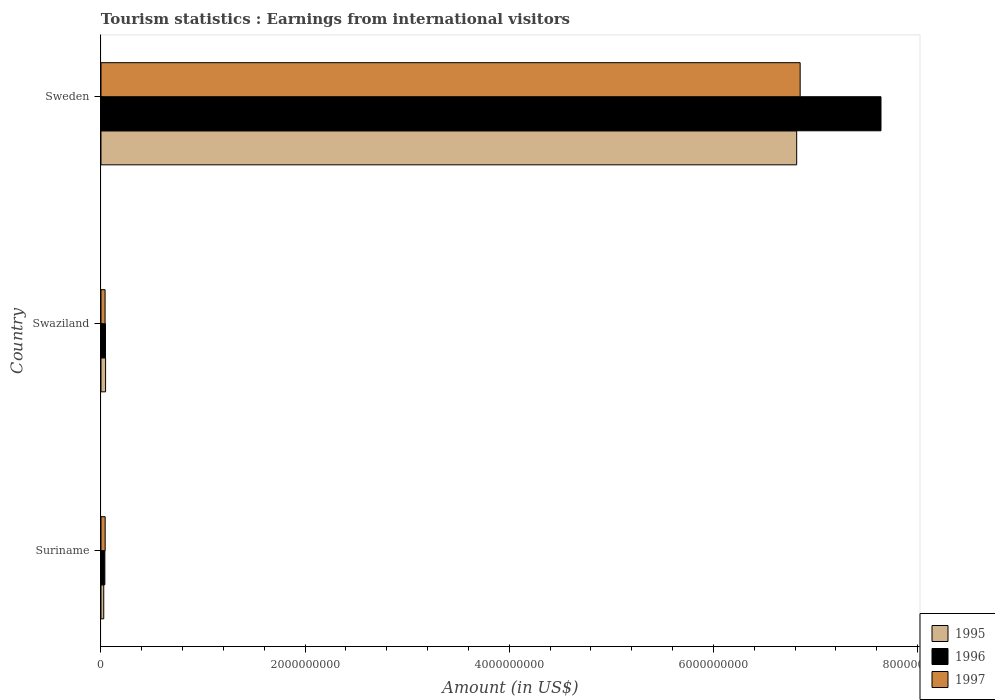How many groups of bars are there?
Offer a very short reply. 3. Are the number of bars per tick equal to the number of legend labels?
Make the answer very short. Yes. How many bars are there on the 2nd tick from the top?
Offer a terse response. 3. What is the earnings from international visitors in 1995 in Swaziland?
Provide a succinct answer. 4.50e+07. Across all countries, what is the maximum earnings from international visitors in 1996?
Keep it short and to the point. 7.64e+09. Across all countries, what is the minimum earnings from international visitors in 1997?
Provide a succinct answer. 4.00e+07. In which country was the earnings from international visitors in 1997 minimum?
Your answer should be compact. Swaziland. What is the total earnings from international visitors in 1997 in the graph?
Offer a very short reply. 6.93e+09. What is the difference between the earnings from international visitors in 1997 in Suriname and that in Sweden?
Offer a terse response. -6.81e+09. What is the difference between the earnings from international visitors in 1996 in Suriname and the earnings from international visitors in 1997 in Sweden?
Offer a very short reply. -6.81e+09. What is the average earnings from international visitors in 1995 per country?
Provide a short and direct response. 2.30e+09. What is the difference between the earnings from international visitors in 1996 and earnings from international visitors in 1997 in Suriname?
Make the answer very short. -3.00e+06. In how many countries, is the earnings from international visitors in 1997 greater than 800000000 US$?
Offer a terse response. 1. What is the ratio of the earnings from international visitors in 1996 in Suriname to that in Swaziland?
Offer a terse response. 0.86. Is the difference between the earnings from international visitors in 1996 in Swaziland and Sweden greater than the difference between the earnings from international visitors in 1997 in Swaziland and Sweden?
Keep it short and to the point. No. What is the difference between the highest and the second highest earnings from international visitors in 1997?
Ensure brevity in your answer.  6.81e+09. What is the difference between the highest and the lowest earnings from international visitors in 1997?
Ensure brevity in your answer.  6.81e+09. In how many countries, is the earnings from international visitors in 1995 greater than the average earnings from international visitors in 1995 taken over all countries?
Your response must be concise. 1. Is the sum of the earnings from international visitors in 1995 in Suriname and Sweden greater than the maximum earnings from international visitors in 1997 across all countries?
Offer a terse response. No. What does the 1st bar from the bottom in Suriname represents?
Ensure brevity in your answer.  1995. How many bars are there?
Your answer should be very brief. 9. Are all the bars in the graph horizontal?
Provide a short and direct response. Yes. Are the values on the major ticks of X-axis written in scientific E-notation?
Keep it short and to the point. No. How are the legend labels stacked?
Give a very brief answer. Vertical. What is the title of the graph?
Give a very brief answer. Tourism statistics : Earnings from international visitors. What is the label or title of the X-axis?
Provide a short and direct response. Amount (in US$). What is the Amount (in US$) of 1995 in Suriname?
Your answer should be compact. 2.70e+07. What is the Amount (in US$) in 1996 in Suriname?
Offer a very short reply. 3.80e+07. What is the Amount (in US$) in 1997 in Suriname?
Ensure brevity in your answer.  4.10e+07. What is the Amount (in US$) in 1995 in Swaziland?
Keep it short and to the point. 4.50e+07. What is the Amount (in US$) in 1996 in Swaziland?
Provide a succinct answer. 4.40e+07. What is the Amount (in US$) in 1997 in Swaziland?
Provide a succinct answer. 4.00e+07. What is the Amount (in US$) in 1995 in Sweden?
Provide a short and direct response. 6.82e+09. What is the Amount (in US$) in 1996 in Sweden?
Provide a succinct answer. 7.64e+09. What is the Amount (in US$) of 1997 in Sweden?
Offer a terse response. 6.85e+09. Across all countries, what is the maximum Amount (in US$) in 1995?
Offer a terse response. 6.82e+09. Across all countries, what is the maximum Amount (in US$) in 1996?
Your response must be concise. 7.64e+09. Across all countries, what is the maximum Amount (in US$) of 1997?
Give a very brief answer. 6.85e+09. Across all countries, what is the minimum Amount (in US$) of 1995?
Provide a short and direct response. 2.70e+07. Across all countries, what is the minimum Amount (in US$) of 1996?
Keep it short and to the point. 3.80e+07. Across all countries, what is the minimum Amount (in US$) in 1997?
Provide a short and direct response. 4.00e+07. What is the total Amount (in US$) of 1995 in the graph?
Ensure brevity in your answer.  6.89e+09. What is the total Amount (in US$) in 1996 in the graph?
Your response must be concise. 7.72e+09. What is the total Amount (in US$) of 1997 in the graph?
Ensure brevity in your answer.  6.93e+09. What is the difference between the Amount (in US$) of 1995 in Suriname and that in Swaziland?
Keep it short and to the point. -1.80e+07. What is the difference between the Amount (in US$) of 1996 in Suriname and that in Swaziland?
Provide a succinct answer. -6.00e+06. What is the difference between the Amount (in US$) of 1995 in Suriname and that in Sweden?
Your answer should be compact. -6.79e+09. What is the difference between the Amount (in US$) in 1996 in Suriname and that in Sweden?
Make the answer very short. -7.60e+09. What is the difference between the Amount (in US$) in 1997 in Suriname and that in Sweden?
Your response must be concise. -6.81e+09. What is the difference between the Amount (in US$) in 1995 in Swaziland and that in Sweden?
Keep it short and to the point. -6.77e+09. What is the difference between the Amount (in US$) of 1996 in Swaziland and that in Sweden?
Provide a succinct answer. -7.60e+09. What is the difference between the Amount (in US$) in 1997 in Swaziland and that in Sweden?
Offer a very short reply. -6.81e+09. What is the difference between the Amount (in US$) of 1995 in Suriname and the Amount (in US$) of 1996 in Swaziland?
Give a very brief answer. -1.70e+07. What is the difference between the Amount (in US$) of 1995 in Suriname and the Amount (in US$) of 1997 in Swaziland?
Give a very brief answer. -1.30e+07. What is the difference between the Amount (in US$) of 1996 in Suriname and the Amount (in US$) of 1997 in Swaziland?
Your answer should be compact. -2.00e+06. What is the difference between the Amount (in US$) in 1995 in Suriname and the Amount (in US$) in 1996 in Sweden?
Offer a very short reply. -7.62e+09. What is the difference between the Amount (in US$) in 1995 in Suriname and the Amount (in US$) in 1997 in Sweden?
Provide a short and direct response. -6.82e+09. What is the difference between the Amount (in US$) in 1996 in Suriname and the Amount (in US$) in 1997 in Sweden?
Keep it short and to the point. -6.81e+09. What is the difference between the Amount (in US$) in 1995 in Swaziland and the Amount (in US$) in 1996 in Sweden?
Make the answer very short. -7.60e+09. What is the difference between the Amount (in US$) in 1995 in Swaziland and the Amount (in US$) in 1997 in Sweden?
Offer a very short reply. -6.80e+09. What is the difference between the Amount (in US$) in 1996 in Swaziland and the Amount (in US$) in 1997 in Sweden?
Keep it short and to the point. -6.81e+09. What is the average Amount (in US$) of 1995 per country?
Keep it short and to the point. 2.30e+09. What is the average Amount (in US$) of 1996 per country?
Offer a very short reply. 2.57e+09. What is the average Amount (in US$) of 1997 per country?
Your response must be concise. 2.31e+09. What is the difference between the Amount (in US$) in 1995 and Amount (in US$) in 1996 in Suriname?
Your answer should be very brief. -1.10e+07. What is the difference between the Amount (in US$) of 1995 and Amount (in US$) of 1997 in Suriname?
Provide a succinct answer. -1.40e+07. What is the difference between the Amount (in US$) of 1995 and Amount (in US$) of 1996 in Swaziland?
Offer a terse response. 1.00e+06. What is the difference between the Amount (in US$) in 1995 and Amount (in US$) in 1997 in Swaziland?
Provide a succinct answer. 5.00e+06. What is the difference between the Amount (in US$) in 1995 and Amount (in US$) in 1996 in Sweden?
Make the answer very short. -8.26e+08. What is the difference between the Amount (in US$) of 1995 and Amount (in US$) of 1997 in Sweden?
Offer a very short reply. -3.40e+07. What is the difference between the Amount (in US$) in 1996 and Amount (in US$) in 1997 in Sweden?
Keep it short and to the point. 7.92e+08. What is the ratio of the Amount (in US$) in 1995 in Suriname to that in Swaziland?
Offer a terse response. 0.6. What is the ratio of the Amount (in US$) in 1996 in Suriname to that in Swaziland?
Your response must be concise. 0.86. What is the ratio of the Amount (in US$) in 1997 in Suriname to that in Swaziland?
Your answer should be very brief. 1.02. What is the ratio of the Amount (in US$) of 1995 in Suriname to that in Sweden?
Your answer should be very brief. 0. What is the ratio of the Amount (in US$) in 1996 in Suriname to that in Sweden?
Offer a terse response. 0.01. What is the ratio of the Amount (in US$) in 1997 in Suriname to that in Sweden?
Make the answer very short. 0.01. What is the ratio of the Amount (in US$) in 1995 in Swaziland to that in Sweden?
Keep it short and to the point. 0.01. What is the ratio of the Amount (in US$) in 1996 in Swaziland to that in Sweden?
Your answer should be very brief. 0.01. What is the ratio of the Amount (in US$) of 1997 in Swaziland to that in Sweden?
Your answer should be compact. 0.01. What is the difference between the highest and the second highest Amount (in US$) of 1995?
Your answer should be very brief. 6.77e+09. What is the difference between the highest and the second highest Amount (in US$) in 1996?
Give a very brief answer. 7.60e+09. What is the difference between the highest and the second highest Amount (in US$) of 1997?
Your answer should be compact. 6.81e+09. What is the difference between the highest and the lowest Amount (in US$) of 1995?
Provide a succinct answer. 6.79e+09. What is the difference between the highest and the lowest Amount (in US$) in 1996?
Make the answer very short. 7.60e+09. What is the difference between the highest and the lowest Amount (in US$) of 1997?
Keep it short and to the point. 6.81e+09. 